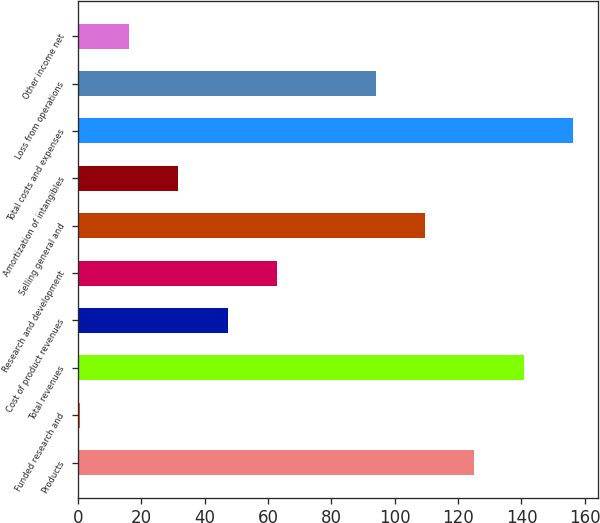<chart> <loc_0><loc_0><loc_500><loc_500><bar_chart><fcel>Products<fcel>Funded research and<fcel>Total revenues<fcel>Cost of product revenues<fcel>Research and development<fcel>Selling general and<fcel>Amortization of intangibles<fcel>Total costs and expenses<fcel>Loss from operations<fcel>Other income net<nl><fcel>125.14<fcel>0.5<fcel>140.72<fcel>47.24<fcel>62.82<fcel>109.56<fcel>31.66<fcel>156.3<fcel>93.98<fcel>16.08<nl></chart> 